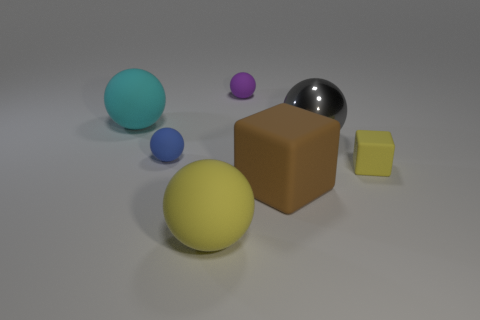What number of objects are either gray metallic spheres or things left of the big yellow rubber ball?
Your answer should be very brief. 3. The matte ball that is in front of the tiny yellow block right of the matte ball that is in front of the small yellow rubber cube is what color?
Offer a terse response. Yellow. There is a sphere that is right of the purple object; what size is it?
Make the answer very short. Large. What number of tiny things are cyan things or red blocks?
Provide a succinct answer. 0. There is a object that is left of the large brown thing and in front of the small yellow rubber thing; what color is it?
Offer a very short reply. Yellow. Are there any tiny rubber objects that have the same shape as the large yellow thing?
Give a very brief answer. Yes. What is the material of the brown object?
Provide a succinct answer. Rubber. Are there any cyan matte spheres behind the yellow ball?
Your response must be concise. Yes. Does the big gray thing have the same shape as the big brown thing?
Make the answer very short. No. How many other objects are the same size as the brown object?
Ensure brevity in your answer.  3. 